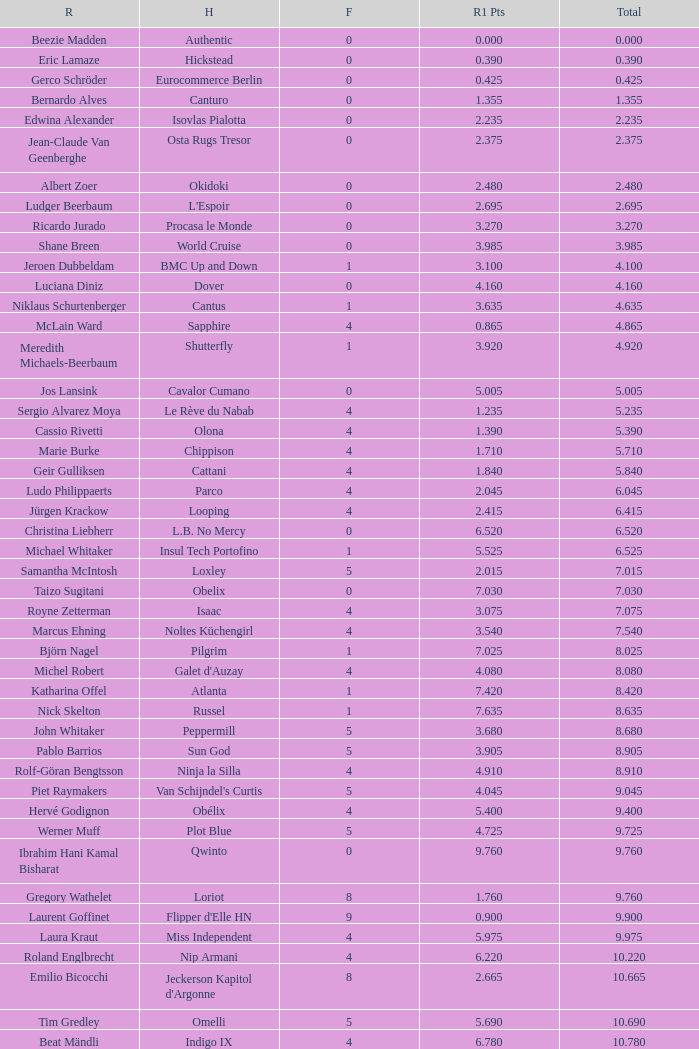Would you mind parsing the complete table? {'header': ['R', 'H', 'F', 'R1 Pts', 'Total'], 'rows': [['Beezie Madden', 'Authentic', '0', '0.000', '0.000'], ['Eric Lamaze', 'Hickstead', '0', '0.390', '0.390'], ['Gerco Schröder', 'Eurocommerce Berlin', '0', '0.425', '0.425'], ['Bernardo Alves', 'Canturo', '0', '1.355', '1.355'], ['Edwina Alexander', 'Isovlas Pialotta', '0', '2.235', '2.235'], ['Jean-Claude Van Geenberghe', 'Osta Rugs Tresor', '0', '2.375', '2.375'], ['Albert Zoer', 'Okidoki', '0', '2.480', '2.480'], ['Ludger Beerbaum', "L'Espoir", '0', '2.695', '2.695'], ['Ricardo Jurado', 'Procasa le Monde', '0', '3.270', '3.270'], ['Shane Breen', 'World Cruise', '0', '3.985', '3.985'], ['Jeroen Dubbeldam', 'BMC Up and Down', '1', '3.100', '4.100'], ['Luciana Diniz', 'Dover', '0', '4.160', '4.160'], ['Niklaus Schurtenberger', 'Cantus', '1', '3.635', '4.635'], ['McLain Ward', 'Sapphire', '4', '0.865', '4.865'], ['Meredith Michaels-Beerbaum', 'Shutterfly', '1', '3.920', '4.920'], ['Jos Lansink', 'Cavalor Cumano', '0', '5.005', '5.005'], ['Sergio Alvarez Moya', 'Le Rève du Nabab', '4', '1.235', '5.235'], ['Cassio Rivetti', 'Olona', '4', '1.390', '5.390'], ['Marie Burke', 'Chippison', '4', '1.710', '5.710'], ['Geir Gulliksen', 'Cattani', '4', '1.840', '5.840'], ['Ludo Philippaerts', 'Parco', '4', '2.045', '6.045'], ['Jürgen Krackow', 'Looping', '4', '2.415', '6.415'], ['Christina Liebherr', 'L.B. No Mercy', '0', '6.520', '6.520'], ['Michael Whitaker', 'Insul Tech Portofino', '1', '5.525', '6.525'], ['Samantha McIntosh', 'Loxley', '5', '2.015', '7.015'], ['Taizo Sugitani', 'Obelix', '0', '7.030', '7.030'], ['Royne Zetterman', 'Isaac', '4', '3.075', '7.075'], ['Marcus Ehning', 'Noltes Küchengirl', '4', '3.540', '7.540'], ['Björn Nagel', 'Pilgrim', '1', '7.025', '8.025'], ['Michel Robert', "Galet d'Auzay", '4', '4.080', '8.080'], ['Katharina Offel', 'Atlanta', '1', '7.420', '8.420'], ['Nick Skelton', 'Russel', '1', '7.635', '8.635'], ['John Whitaker', 'Peppermill', '5', '3.680', '8.680'], ['Pablo Barrios', 'Sun God', '5', '3.905', '8.905'], ['Rolf-Göran Bengtsson', 'Ninja la Silla', '4', '4.910', '8.910'], ['Piet Raymakers', "Van Schijndel's Curtis", '5', '4.045', '9.045'], ['Hervé Godignon', 'Obélix', '4', '5.400', '9.400'], ['Werner Muff', 'Plot Blue', '5', '4.725', '9.725'], ['Ibrahim Hani Kamal Bisharat', 'Qwinto', '0', '9.760', '9.760'], ['Gregory Wathelet', 'Loriot', '8', '1.760', '9.760'], ['Laurent Goffinet', "Flipper d'Elle HN", '9', '0.900', '9.900'], ['Laura Kraut', 'Miss Independent', '4', '5.975', '9.975'], ['Roland Englbrecht', 'Nip Armani', '4', '6.220', '10.220'], ['Emilio Bicocchi', "Jeckerson Kapitol d'Argonne", '8', '2.665', '10.665'], ['Tim Gredley', 'Omelli', '5', '5.690', '10.690'], ['Beat Mändli', 'Indigo IX', '4', '6.780', '10.780'], ['Christian Ahlmann', 'Cöster', '8', '4.000', '12.000'], ['Tina Lund', 'Carola', '9', '3.610', '12.610'], ['Max Amaya', 'Church Road', '8', '4.790', '12.790'], ['Álvaro Alfonso de Miranda Neto', 'Nike', '9', '4.235', '13.235'], ['Jesus Garmendia Echeverria', 'Maddock', '8', '5.335', '13.335'], ['Carlos Lopez', 'Instit', '10', '3.620', '13.620'], ['Juan Carlos García', 'Loro Piana Albin III', '5', '9.020', '14.020'], ['Cameron Hanley', 'Siec Hippica Kerman', '9', '5.375', '14.375'], ['Ricardo Kierkegaard', 'Rey Z', '8', '6.805', '14.805'], ['Jill Henselwood', 'Special Ed', '9', '6.165', '15.165'], ['Margie Engle', "Hidden Creek's Quervo Gold", '4', '12.065', '16.065'], ['Judy-Ann Melchoir', 'Grande Dame Z', '9', '7.310', '16.310'], ['Maria Gretzer', 'Spender S', '9', '7.385', '16.385'], ['Billy Twomey', 'Luidam', '9', '7.615', '16.615'], ['Federico Fernandez', 'Bohemio', '8', '9.610', '17.610'], ['Jonella Ligresti', 'Quinta 27', '6', '12.365', '18.365'], ['Ian Millar', 'In Style', '9', '9.370', '18.370'], ['Mikael Forsten', "BMC's Skybreaker", '12', '6.435', '18.435'], ['Sebastian Numminen', 'Sails Away', '13', '5.455', '18.455'], ['Stefan Eder', 'Cartier PSG', '12', '6.535', '18.535'], ['Dirk Demeersman', 'Clinton', '16', '2.755', '18.755'], ['Antonis Petris', 'Gredo la Daviere', '13', '6.300', '19.300'], ['Gunnar Klettenberg', 'Novesta', '9', '10.620', '19.620'], ['Syed Omar Almohdzar', 'Lui', '10', '9.820', '19.820'], ['Tony Andre Hansen', 'Camiro', '13', '7.245', '20.245'], ['Manuel Fernandez Saro', 'Quin Chin', '13', '7.465', '20.465'], ['James Wingrave', 'Agropoint Calira', '14', '6.855', '20.855'], ['Rod Brown', 'Mr. Burns', '9', '12.300', '21.300'], ['Jiri Papousek', 'La Manche T', '13', '8.440', '21.440'], ['Marcela Lobo', 'Joskin', '14', '7.600', '21.600'], ['Yuko Itakura', 'Portvliet', '9', '12.655', '21.655'], ['Zsolt Pirik', 'Havanna', '9', '13.050', '22.050'], ['Fabrice Lyon', 'Jasmine du Perron', '11', '12.760', '23.760'], ['Florian Angot', 'First de Launay', '16', '8.055', '24.055'], ['Peter McMahon', 'Kolora Stud Genoa', '9', '15.195', '24.195'], ['Giuseppe Rolli', 'Jericho de la Vie', '17', '7.910', '24.910'], ['Alberto Michan', 'Chinobampo Lavita', '13', '12.330', '25.330'], ['Hanno Ellermann', 'Poncorde', '17', '8.600', '25.600'], ['Antonio Portela Carneiro', 'Echo de Lessay', '18', '8.565', '26.565'], ['Gerfried Puck', '11th Bleeker', '21', '6.405', '27.405'], ['H.H. Prince Faisal Al-Shalan', 'Uthago', '18', '10.205', '28.205'], ['Vladimir Beletskiy', 'Rezonanz', '21', '7.725', '28.725'], ['Noora Pentti', 'Evli Cagliostro', '17', '12.455', '29.455'], ['Mohammed Al-Kumaiti', 'Al-Mutawakel', '17', '12.490', '29.490'], ['Guillermo Obligado', 'Carlson', '18', '11.545', '29.545'], ['Kamal Bahamdan', 'Campus', '17', '13.190', '30.190'], ['Veronika Macanova', 'Pompos', '13', '18.185', '31.185'], ['Vladimir Panchenko', 'Lanteno', '17', '14.460', '31.460'], ['Jose Larocca', 'Svante', '25', '8.190', '33.190'], ['Abdullah Al-Sharbatly', 'Hugo Gesmeray', '25', '8.585', '33.585'], ['Eiken Sato', 'Cayak DH', '17', '17.960', '34.960'], ['Gennadiy Gashiboyazov', 'Papirus', '28', '8.685', '36.685'], ['Karim El-Zoghby', 'Baragway', '21', '16.360', '37.360'], ['Ondrej Nagr', 'Atlas', '19', '19.865', '38.865'], ['Roger Hessen', 'Quito', '23', '17.410', '40.410'], ['Zdenek Zila', 'Pinot Grigio', '15', '26.035', '41.035'], ['Rene Lopez', 'Isky', '30', '11.675', '41.675'], ['Emmanouela Athanassiades', 'Rimini Z', '18', '24.380', '42.380'], ['Jamie Kermond', 'Stylish King', '21', '46.035', '67.035'], ['Malin Baryard-Johnsson', 'Butterfly Flip', '29', '46.035', '75.035'], ['Manuel Torres', 'Chambacunero', 'Fall', 'Fall', '5.470'], ['Krzyszlof Ludwiczak', 'HOF Schretstakens Quamiro', 'Eliminated', 'Eliminated', '7.460'], ['Grant Wilson', 'Up and Down Cellebroedersbos', 'Refusal', 'Refusal', '14.835'], ['Chris Pratt', 'Rivendell', 'Fall', 'Fall', '15.220'], ['Ariana Azcarraga', 'Sambo', 'Eliminated', 'Eliminated', '15.945'], ['Jose Alfredo Hernandez Ortega', 'Semtex P', 'Eliminated', 'Eliminated', '46.035'], ['H.R.H. Prince Abdullah Al-Soud', 'Allah Jabek', 'Retired', 'Retired', '46.035']]} Tell me the rider with 18.185 points round 1 Veronika Macanova. 